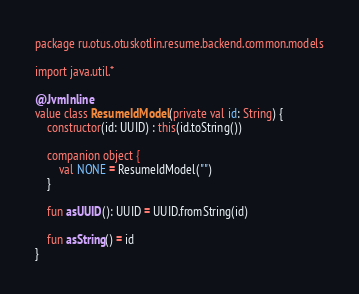<code> <loc_0><loc_0><loc_500><loc_500><_Kotlin_>package ru.otus.otuskotlin.resume.backend.common.models

import java.util.*

@JvmInline
value class ResumeIdModel(private val id: String) {
    constructor(id: UUID) : this(id.toString())

    companion object {
        val NONE = ResumeIdModel("")
    }

    fun asUUID(): UUID = UUID.fromString(id)

    fun asString() = id
}
</code> 